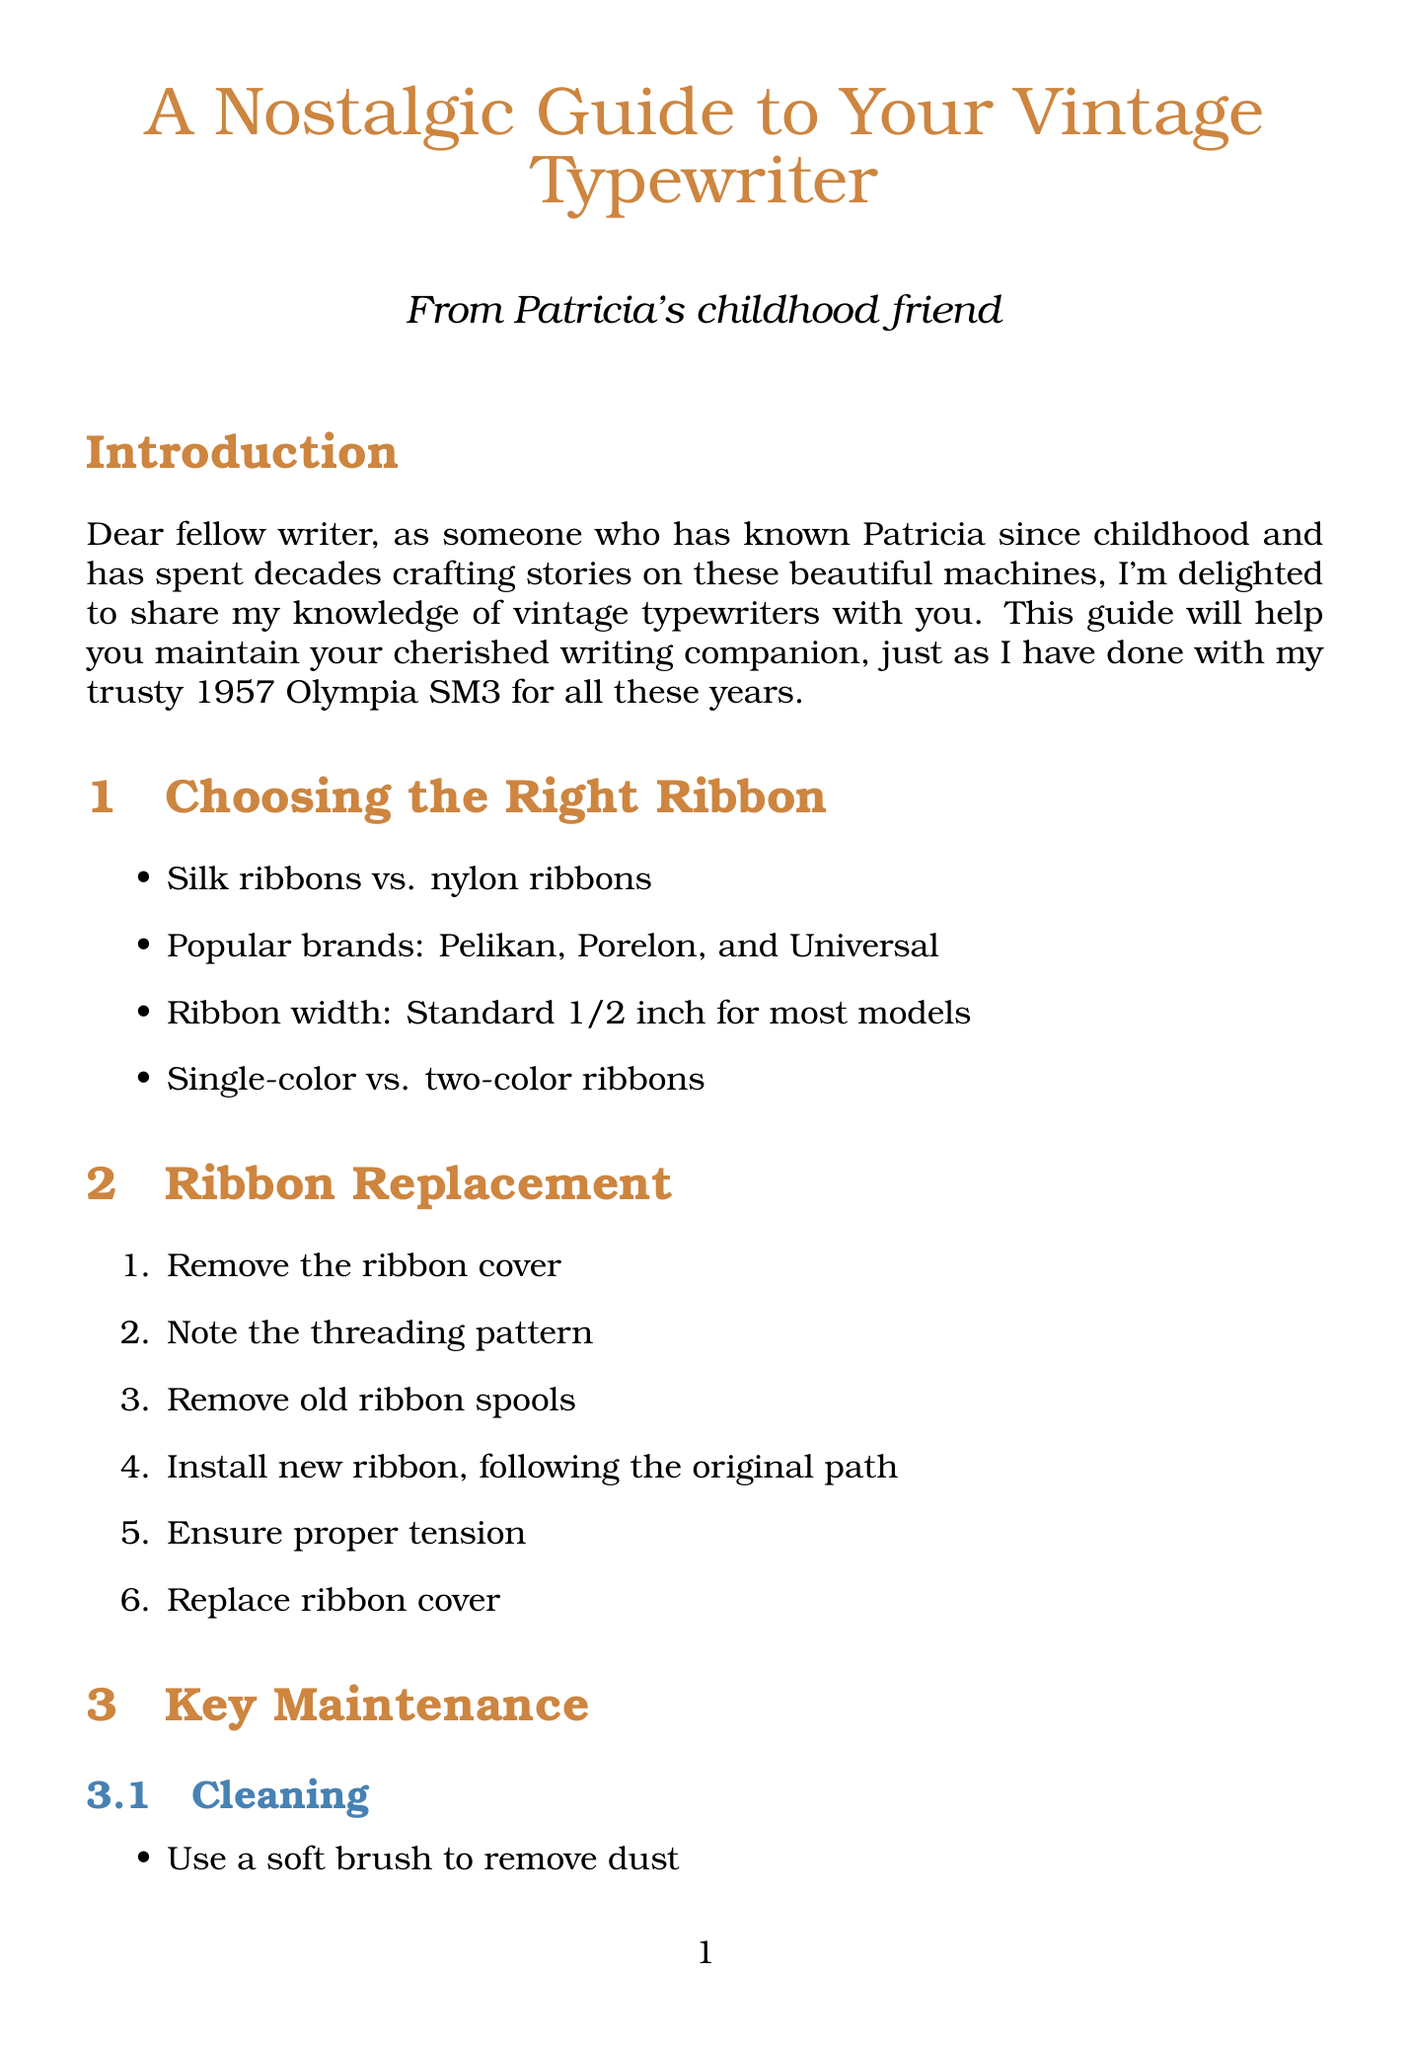What is the title of the document? The title is prominently displayed at the beginning of the document.
Answer: A Nostalgic Guide to Your Vintage Typewriter Who is the author of the document? The author is mentioned at the title section.
Answer: From Patricia's childhood friend What is the standard ribbon width for most models? The ribbon width is specified in the "Choosing the Right Ribbon" section.
Answer: Standard 1/2 inch What is the first step in ribbon replacement? The steps for ribbon replacement are listed in order.
Answer: Remove the ribbon cover Which vintage typewriter model is from the 1960s? The "Common Vintage Typewriter Models" section lists models along with their years.
Answer: Hermes 3000 What should be used to clean sticky keys? The troubleshooting advice for sticky keys is given in the document.
Answer: Denatured alcohol What is a recommended tip for caring for your typewriter? Tips for caring for the typewriter are provided in a list.
Answer: Cover when not in use to prevent dust accumulation How often should you consider professional servicing? The document suggests a frequency for professional servicing.
Answer: Every few years What problem does a faded typing indicate? The troubles for different issues are outlined in the "Troubleshooting" section.
Answer: Replace ribbon or adjust ribbon vibrator 